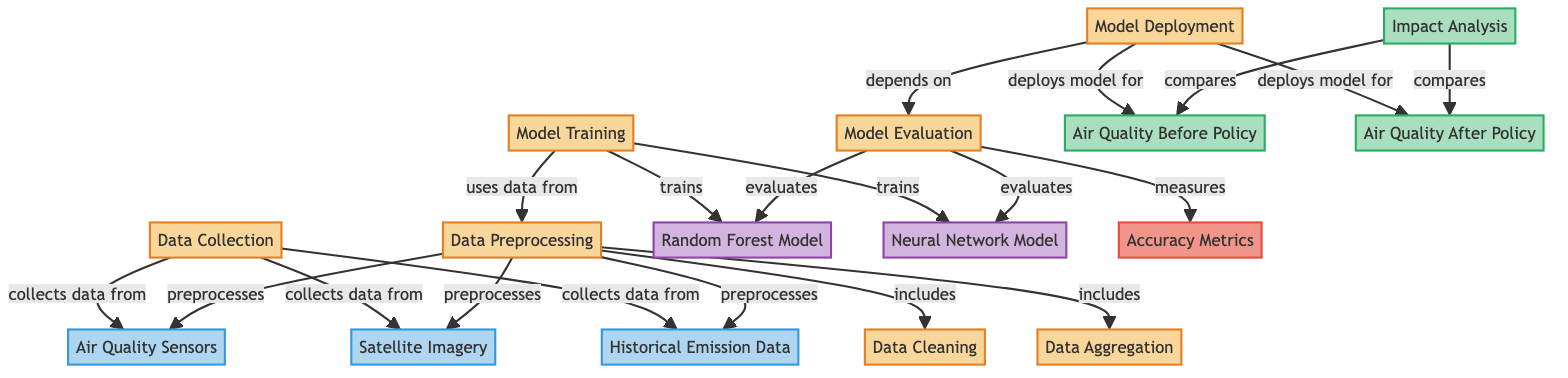What's the first step in the diagram? According to the flow of the diagram, the first action that takes place is "Data Collection," where data is gathered from various sources.
Answer: Data Collection How many models are trained in this diagram? The diagram shows that two models are trained: the "Random Forest Model" and the "Neural Network Model."
Answer: Two What are the sources of data for model training? The "Data Collection" node indicates that data is collected from "Air Quality Sensors," "Satellite Imagery," and "Historical Emission Data" for training the models.
Answer: Air Quality Sensors, Satellite Imagery, Historical Emission Data What is evaluated after model training? The "Model Evaluation" node in the diagram indicates that the models are evaluated for their performance after they have been trained.
Answer: Model Evaluation What follows data preprocessing? After data preprocessing, which consists of cleaning and aggregation, "Model Training" occurs next in the sequence of the diagram.
Answer: Model Training How do the models impact the analysis? The flow indicates that both the "Air Quality Before Policy" and "Air Quality After Policy" are deployed into the "Impact Analysis," which compares the two to derive insights.
Answer: Impact Analysis What type of outcomes are assessed after policy implementation? The outcomes assessed after policy implementation include "Air Quality Before Policy" and "Air Quality After Policy," revealing changes post-implementation.
Answer: Air Quality Before Policy, Air Quality After Policy What algorithms are mentioned for model training? The algorithms indicated in the "Model Training" phase are the "Random Forest Model" and the "Neural Network Model," which are designed to analyze the air quality data.
Answer: Random Forest Model, Neural Network Model What action depends on the model evaluation? The "Model Deployment" action heavily relies on the outcomes from the "Model Evaluation," ensuring only the effective models are used.
Answer: Model Deployment 